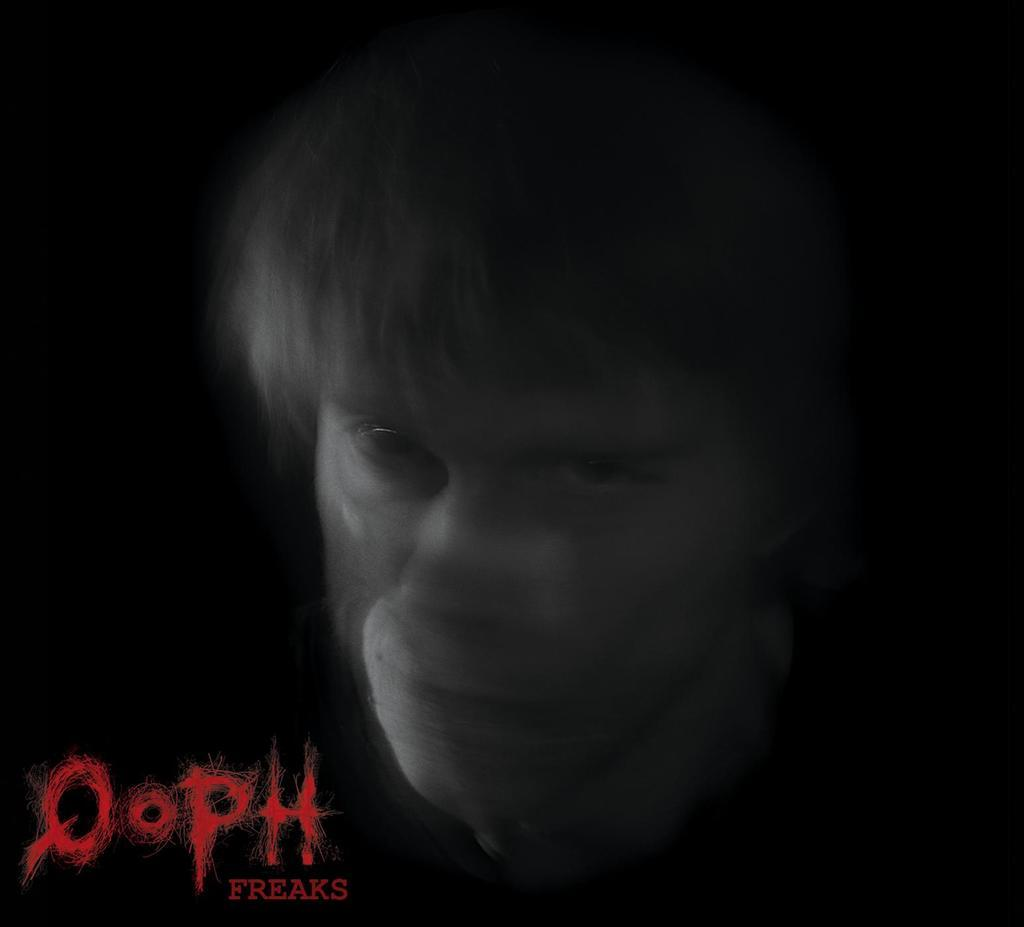What is present in the image? There is a person in the image. What is the person doing in the image? The person is staring. What type of sand can be seen in the image? There is no sand present in the image; it features a person staring. What kind of rat is visible in the image? There is no rat present in the image; it only features a person staring. 